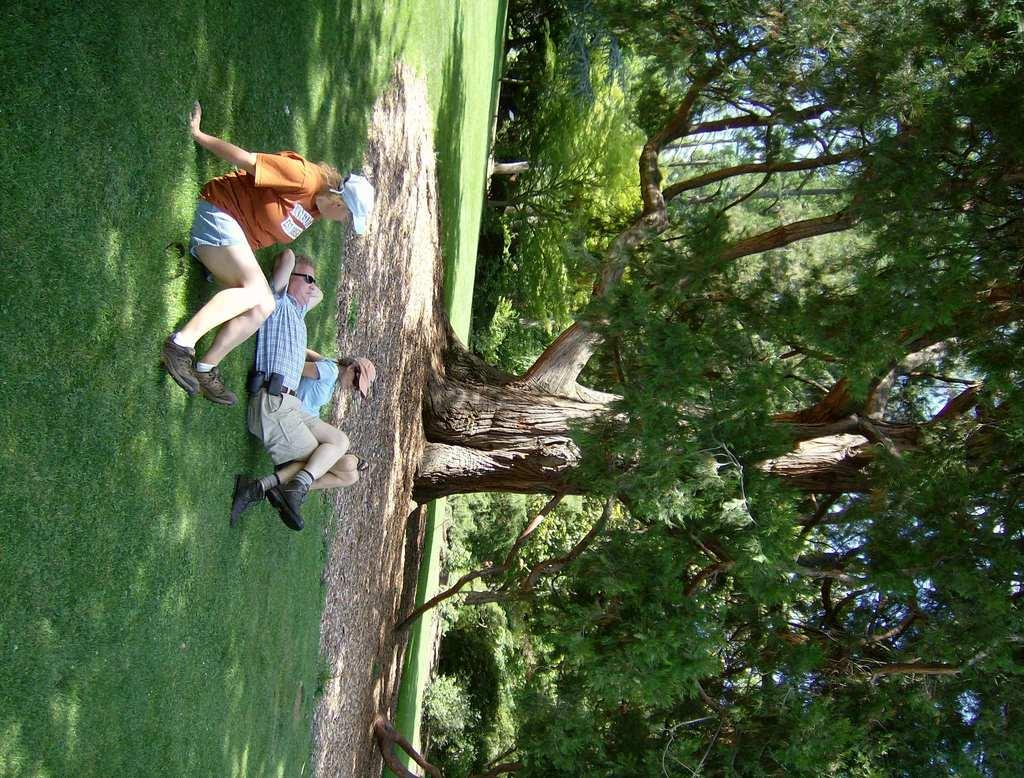Who is present in the image? There is a man and two women in the image. What is the man doing in the image? The man is sleeping on the ground. What are the women doing in the image? The women are sitting on the ground. What can be seen in the background of the image? There are trees in the background of the image. What type of argument can be heard between the man and the women in the image? There is no argument present in the image; the man is sleeping and the women are sitting. Can you tell me where the cup is located in the image? There is no cup present in the image. 